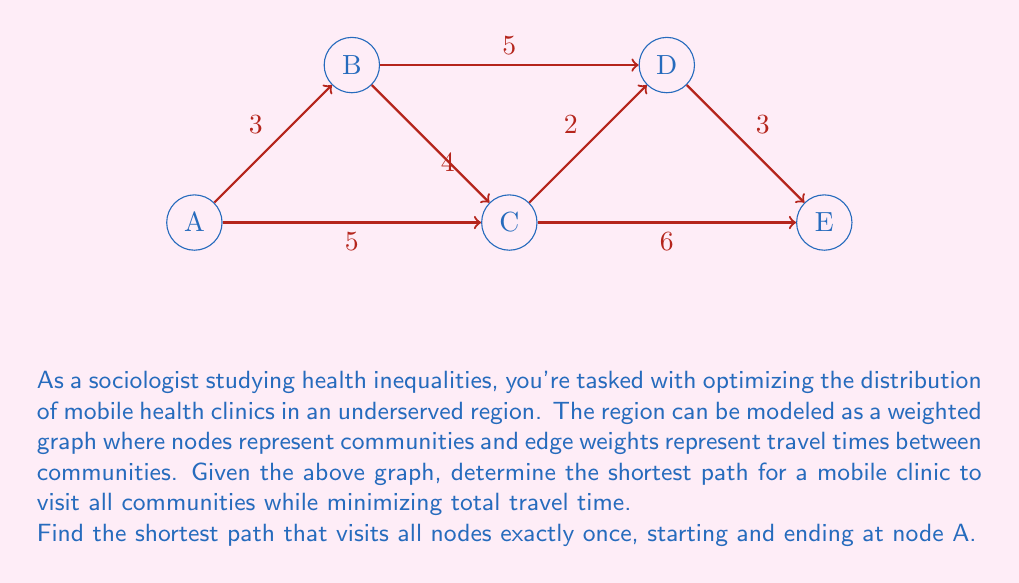What is the answer to this math problem? To solve this problem, we'll use the Held-Karp algorithm, which is an efficient dynamic programming approach for solving the Traveling Salesman Problem (TSP).

Step 1: Initialize the base cases
Let $C(S, i)$ be the cost of the shortest path visiting all vertices in set $S$ and ending at vertex $i$.
For all $i \neq A$: $C(\{i\}, i) = \text{distance}(A, i)$

Step 2: Build the dynamic programming table
For subsets $S$ of size 2 to $n-1$:
  For each $i \in S$:
    $C(S, i) = \min_{j \in S, j \neq i} \{C(S - \{i\}, j) + \text{distance}(j, i)\}$

Step 3: Find the optimal solution
$\text{optimal} = \min_{i \neq A} \{C(V - \{A\}, i) + \text{distance}(i, A)\}$

Applying this to our graph:

Base cases:
$C(\{B\}, B) = 3$
$C(\{C\}, C) = 5$
$C(\{D\}, D) = 10$
$C(\{E\}, E) = 11$

Building the table:
$C(\{B,C\}, B) = 9$
$C(\{B,C\}, C) = 7$
$C(\{B,D\}, B) = 13$
$C(\{B,D\}, D) = 8$
$C(\{B,E\}, B) = 14$
$C(\{B,E\}, E) = 14$
$C(\{C,D\}, C) = 12$
$C(\{C,D\}, D) = 7$
$C(\{C,E\}, C) = 11$
$C(\{C,E\}, E) = 11$
$C(\{D,E\}, D) = 13$
$C(\{D,E\}, E) = 13$

$C(\{B,C,D\}, B) = 14$
$C(\{B,C,D\}, C) = 9$
$C(\{B,C,D\}, D) = 9$
$C(\{B,C,E\}, B) = 15$
$C(\{B,C,E\}, C) = 13$
$C(\{B,C,E\}, E) = 13$
$C(\{B,D,E\}, B) = 16$
$C(\{B,D,E\}, D) = 11$
$C(\{B,D,E\}, E) = 16$
$C(\{C,D,E\}, C) = 13$
$C(\{C,D,E\}, D) = 10$
$C(\{C,D,E\}, E) = 14$

$C(\{B,C,D,E\}, B) = 17$
$C(\{B,C,D,E\}, C) = 15$
$C(\{B,C,D,E\}, D) = 12$
$C(\{B,C,D,E\}, E) = 16$

Optimal solution:
$\text{optimal} = \min \{17 + 3, 15 + 5, 12 + 10, 16 + 11\} = 20$

The shortest path is A -> C -> B -> D -> E -> A, with a total distance of 20.
Answer: A -> C -> B -> D -> E -> A, total distance: 20 